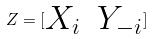<formula> <loc_0><loc_0><loc_500><loc_500>Z = [ \begin{matrix} X _ { i } & Y _ { - i } \end{matrix} ]</formula> 